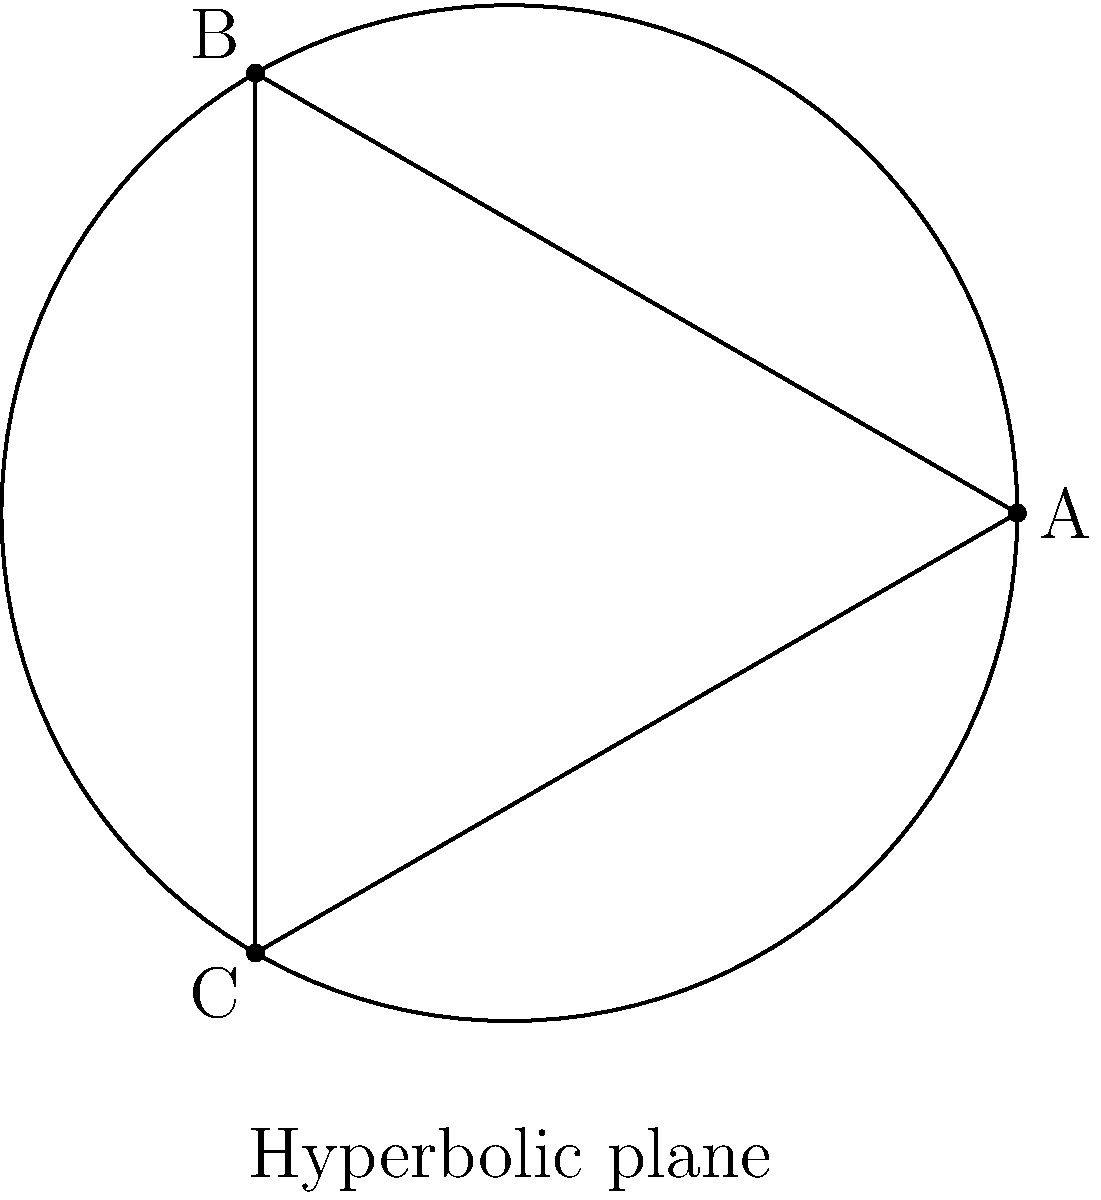In the hyperbolic plane shown above, consider the triangle ABC. How does the sum of its interior angles compare to that of a triangle in Euclidean geometry? To understand this, let's follow these steps:

1) In Euclidean geometry, the sum of interior angles of a triangle is always 180°.

2) However, in hyperbolic geometry, which is a type of non-Euclidean geometry with negative curvature, this rule doesn't hold.

3) In hyperbolic geometry, the sum of the interior angles of a triangle is always less than 180°.

4) This is due to the negative curvature of the hyperbolic plane, which causes parallel lines to diverge and angles to appear smaller than they would in Euclidean space.

5) The exact sum depends on the size of the triangle. The larger the triangle (in terms of area), the smaller the sum of its interior angles.

6) This property is described by the Gauss-Bonnet theorem, which relates the geometry of surfaces to their topology.

7) The theorem states that for a hyperbolic triangle, $\alpha + \beta + \gamma = \pi - A$, where $\alpha$, $\beta$, and $\gamma$ are the interior angles, $\pi$ is 180° in radians, and $A$ is the area of the triangle.

8) This means that as the area of the triangle increases, the sum of its interior angles decreases, always remaining less than 180°.
Answer: Less than 180° 